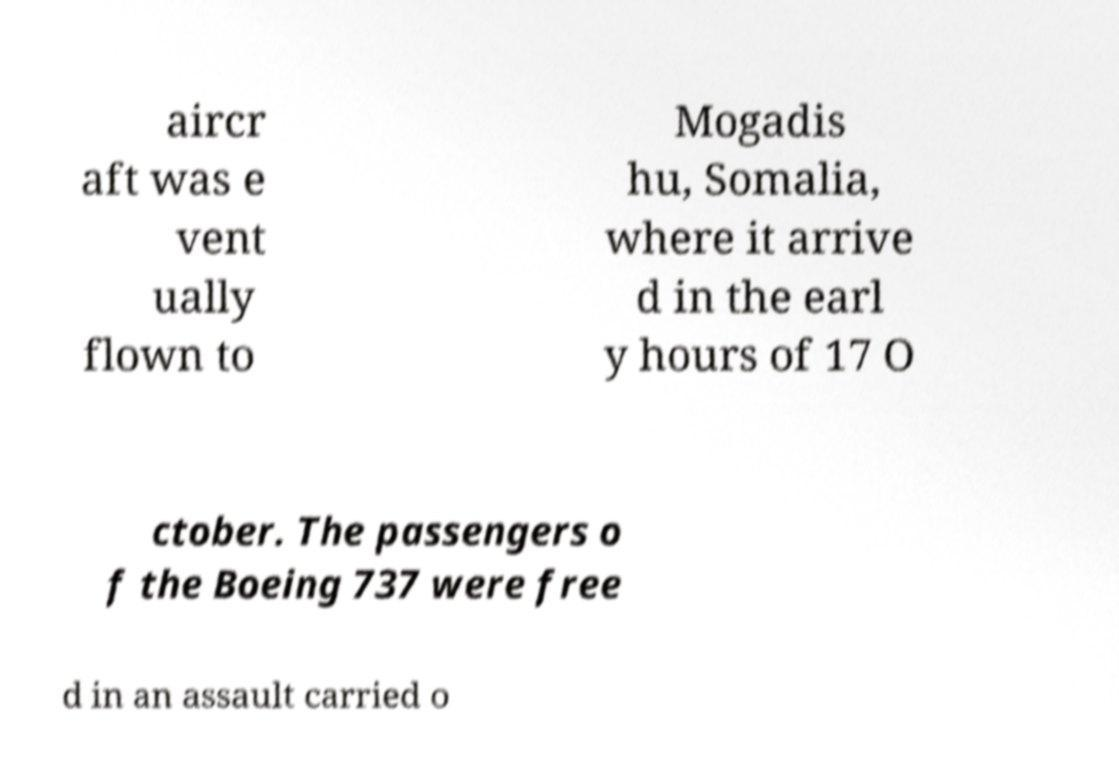Can you accurately transcribe the text from the provided image for me? aircr aft was e vent ually flown to Mogadis hu, Somalia, where it arrive d in the earl y hours of 17 O ctober. The passengers o f the Boeing 737 were free d in an assault carried o 